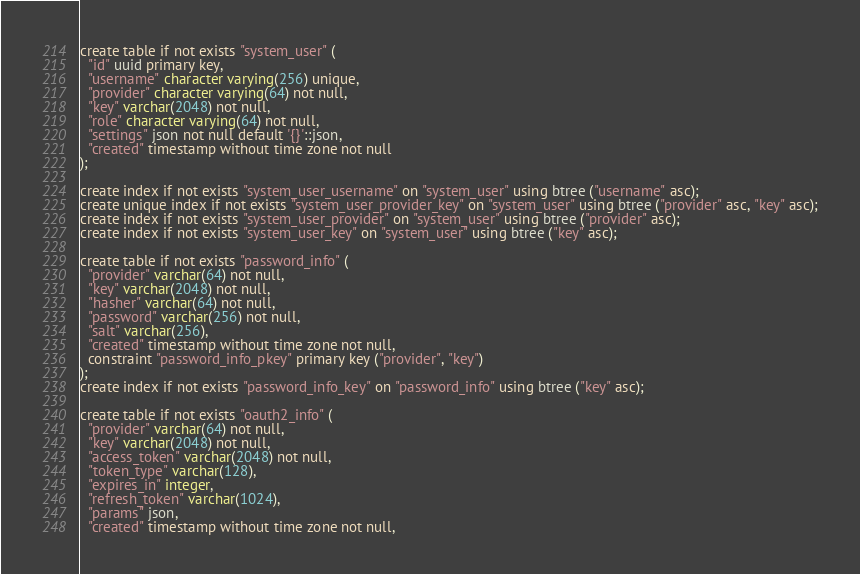<code> <loc_0><loc_0><loc_500><loc_500><_SQL_>create table if not exists "system_user" (
  "id" uuid primary key,
  "username" character varying(256) unique,
  "provider" character varying(64) not null,
  "key" varchar(2048) not null,
  "role" character varying(64) not null,
  "settings" json not null default '{}'::json,
  "created" timestamp without time zone not null
);

create index if not exists "system_user_username" on "system_user" using btree ("username" asc);
create unique index if not exists "system_user_provider_key" on "system_user" using btree ("provider" asc, "key" asc);
create index if not exists "system_user_provider" on "system_user" using btree ("provider" asc);
create index if not exists "system_user_key" on "system_user" using btree ("key" asc);

create table if not exists "password_info" (
  "provider" varchar(64) not null,
  "key" varchar(2048) not null,
  "hasher" varchar(64) not null,
  "password" varchar(256) not null,
  "salt" varchar(256),
  "created" timestamp without time zone not null,
  constraint "password_info_pkey" primary key ("provider", "key")
);
create index if not exists "password_info_key" on "password_info" using btree ("key" asc);

create table if not exists "oauth2_info" (
  "provider" varchar(64) not null,
  "key" varchar(2048) not null,
  "access_token" varchar(2048) not null,
  "token_type" varchar(128),
  "expires_in" integer,
  "refresh_token" varchar(1024),
  "params" json,
  "created" timestamp without time zone not null,</code> 